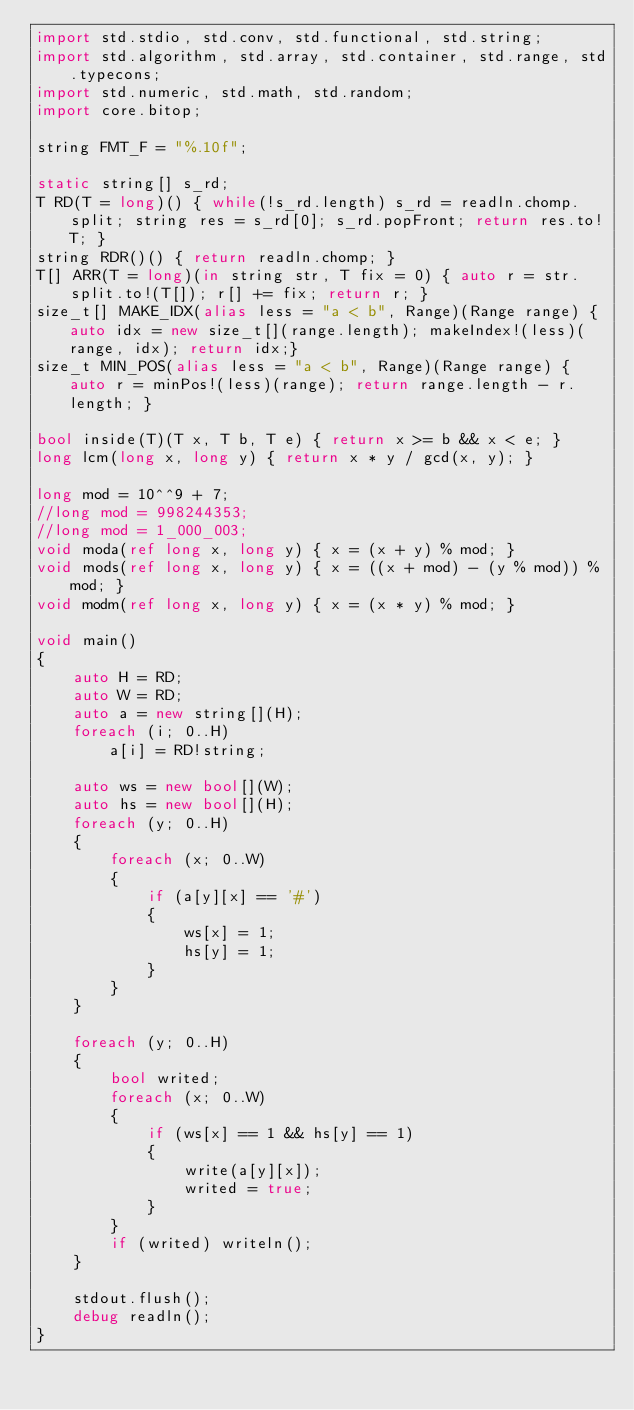Convert code to text. <code><loc_0><loc_0><loc_500><loc_500><_D_>import std.stdio, std.conv, std.functional, std.string;
import std.algorithm, std.array, std.container, std.range, std.typecons;
import std.numeric, std.math, std.random;
import core.bitop;

string FMT_F = "%.10f";

static string[] s_rd;
T RD(T = long)() { while(!s_rd.length) s_rd = readln.chomp.split; string res = s_rd[0]; s_rd.popFront; return res.to!T; }
string RDR()() { return readln.chomp; }
T[] ARR(T = long)(in string str, T fix = 0) { auto r = str.split.to!(T[]); r[] += fix; return r; }
size_t[] MAKE_IDX(alias less = "a < b", Range)(Range range) { auto idx = new size_t[](range.length); makeIndex!(less)(range, idx); return idx;}
size_t MIN_POS(alias less = "a < b", Range)(Range range) { auto r = minPos!(less)(range); return range.length - r.length; }

bool inside(T)(T x, T b, T e) { return x >= b && x < e; }
long lcm(long x, long y) { return x * y / gcd(x, y); }

long mod = 10^^9 + 7;
//long mod = 998244353;
//long mod = 1_000_003;
void moda(ref long x, long y) { x = (x + y) % mod; }
void mods(ref long x, long y) { x = ((x + mod) - (y % mod)) % mod; }
void modm(ref long x, long y) { x = (x * y) % mod; }

void main()
{
	auto H = RD;
	auto W = RD;
	auto a = new string[](H);
	foreach (i; 0..H)
		a[i] = RD!string;
	
	auto ws = new bool[](W);
	auto hs = new bool[](H);
	foreach (y; 0..H)
	{
		foreach (x; 0..W)
		{
			if (a[y][x] == '#')
			{
				ws[x] = 1;
				hs[y] = 1;
			}
		}
	}

	foreach (y; 0..H)
	{
		bool writed;
		foreach (x; 0..W)
		{
			if (ws[x] == 1 && hs[y] == 1)
			{
				write(a[y][x]);
				writed = true;
			}
		}
		if (writed) writeln();
	}
	
	stdout.flush();
	debug readln();
}
</code> 